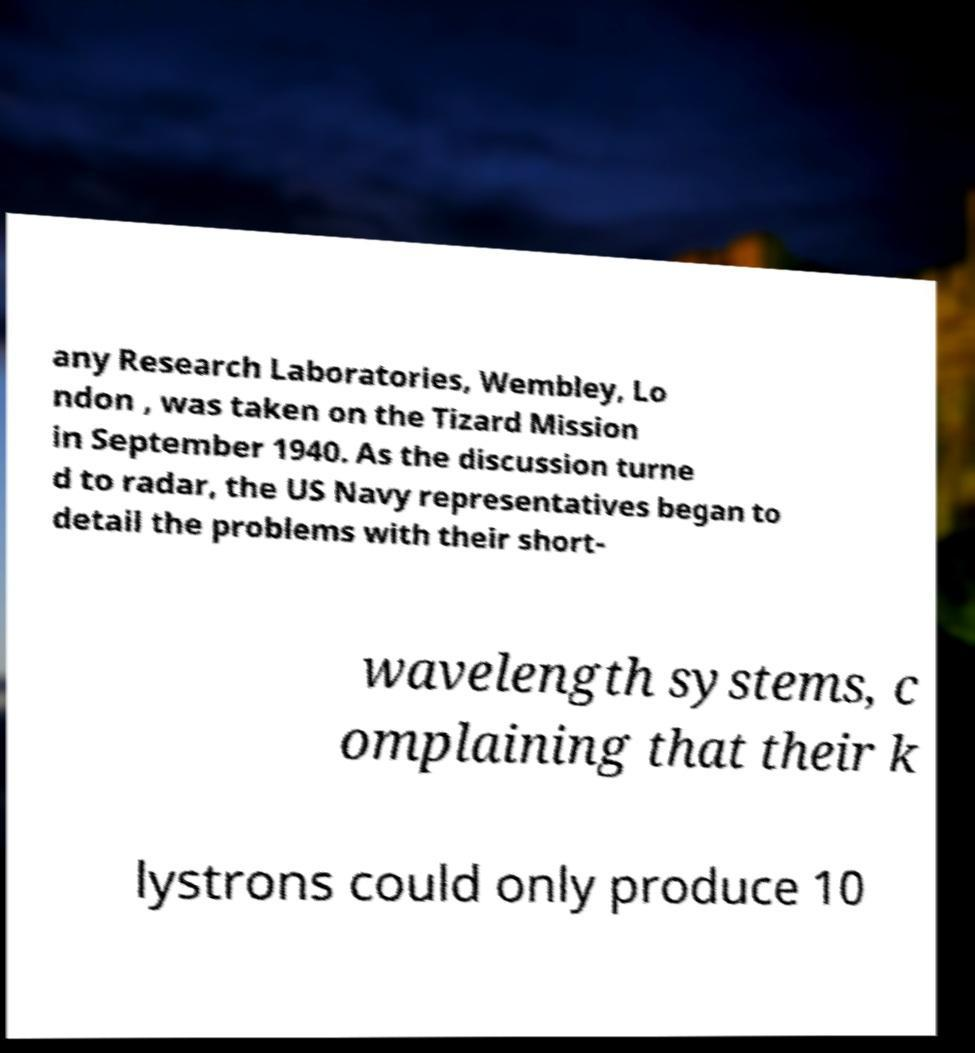Please read and relay the text visible in this image. What does it say? any Research Laboratories, Wembley, Lo ndon , was taken on the Tizard Mission in September 1940. As the discussion turne d to radar, the US Navy representatives began to detail the problems with their short- wavelength systems, c omplaining that their k lystrons could only produce 10 